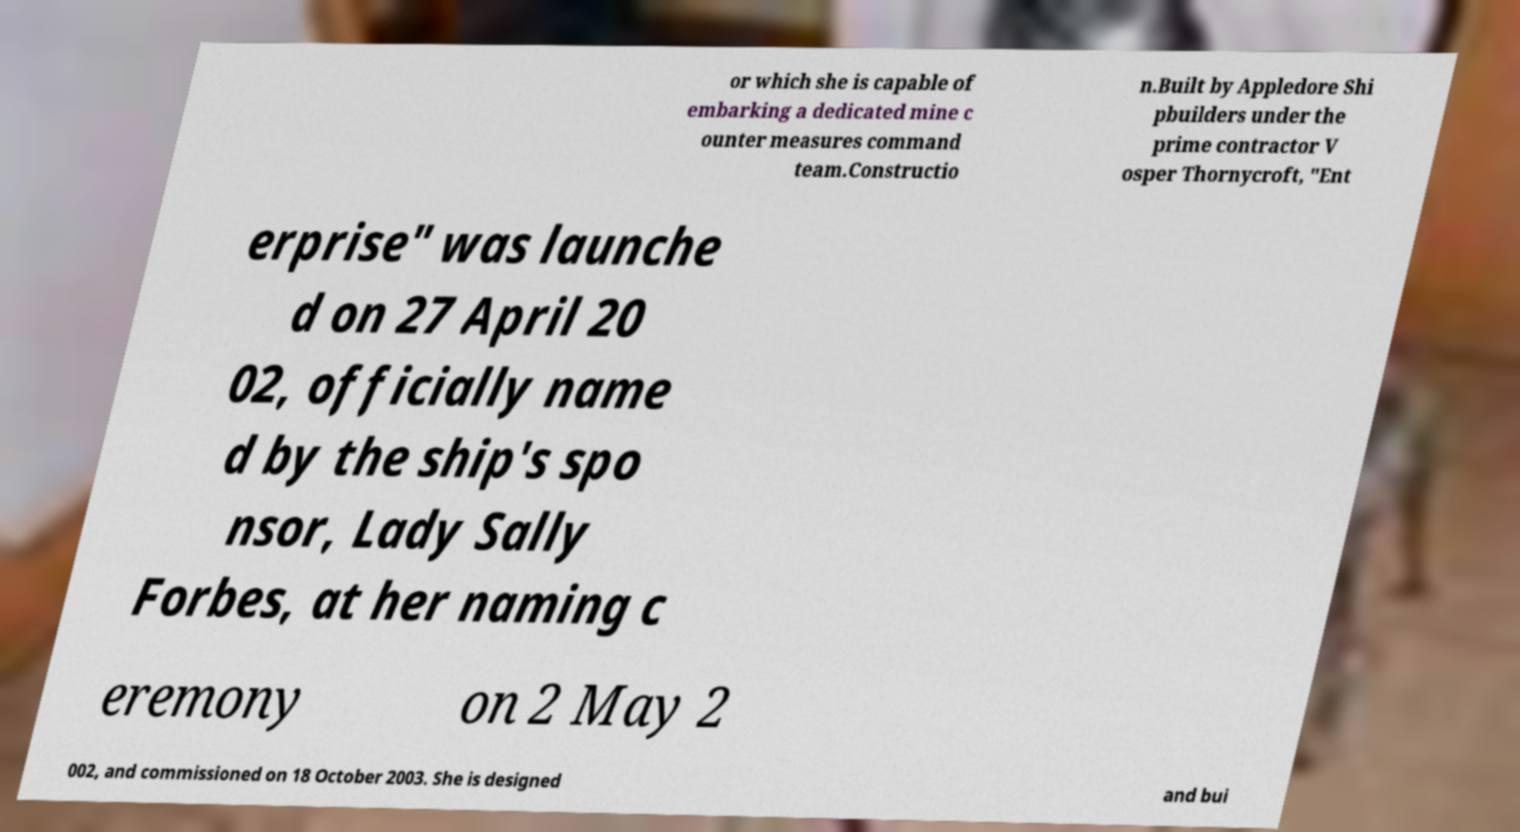Can you read and provide the text displayed in the image?This photo seems to have some interesting text. Can you extract and type it out for me? or which she is capable of embarking a dedicated mine c ounter measures command team.Constructio n.Built by Appledore Shi pbuilders under the prime contractor V osper Thornycroft, "Ent erprise" was launche d on 27 April 20 02, officially name d by the ship's spo nsor, Lady Sally Forbes, at her naming c eremony on 2 May 2 002, and commissioned on 18 October 2003. She is designed and bui 